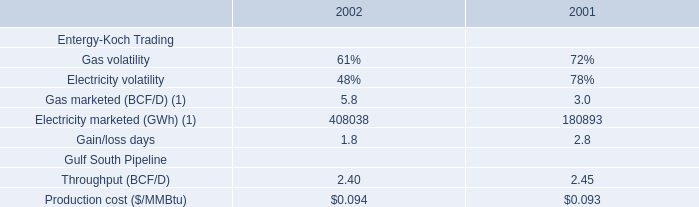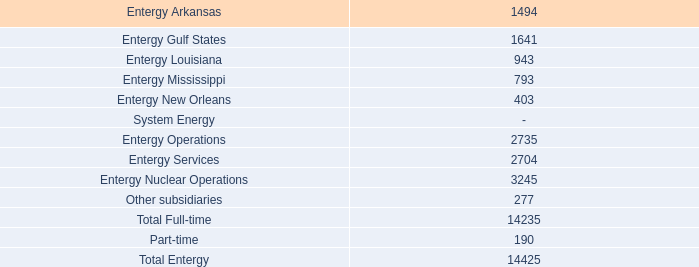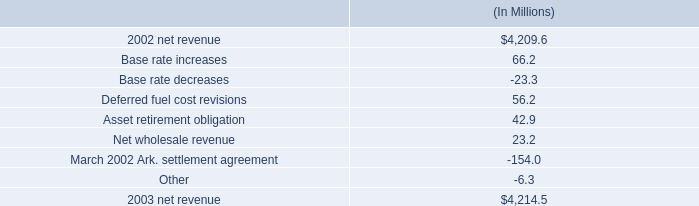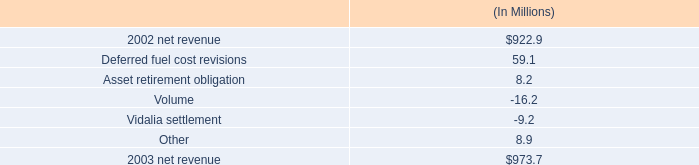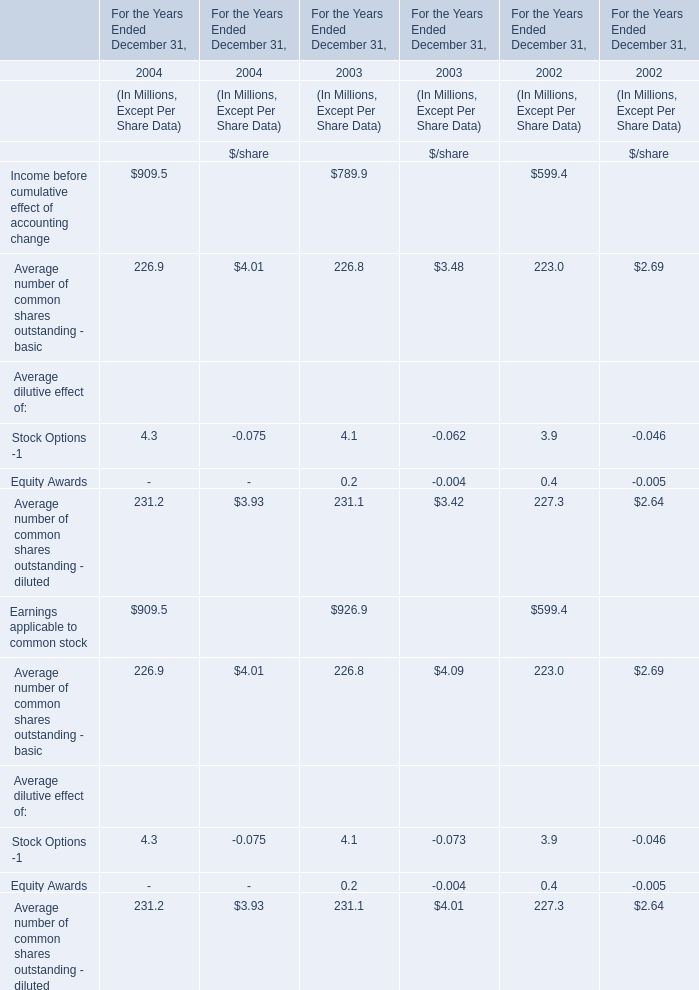What's the total value of all Average dilutive effect that are smaller than 1.0 in 2003? (in Dollars In Millions) 
Answer: 0.2. 